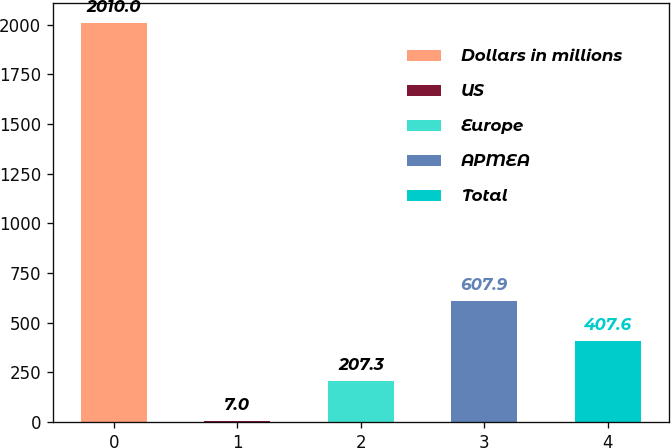<chart> <loc_0><loc_0><loc_500><loc_500><bar_chart><fcel>Dollars in millions<fcel>US<fcel>Europe<fcel>APMEA<fcel>Total<nl><fcel>2010<fcel>7<fcel>207.3<fcel>607.9<fcel>407.6<nl></chart> 